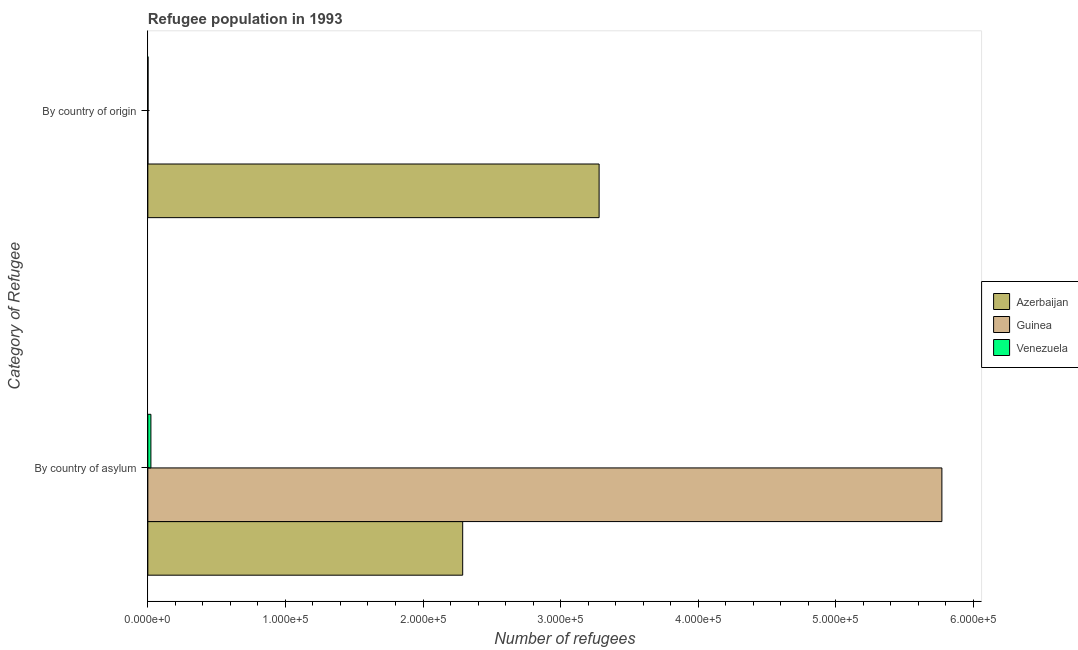How many bars are there on the 2nd tick from the bottom?
Offer a terse response. 3. What is the label of the 2nd group of bars from the top?
Your response must be concise. By country of asylum. What is the number of refugees by country of asylum in Azerbaijan?
Ensure brevity in your answer.  2.29e+05. Across all countries, what is the maximum number of refugees by country of origin?
Your response must be concise. 3.28e+05. Across all countries, what is the minimum number of refugees by country of origin?
Give a very brief answer. 31. In which country was the number of refugees by country of origin maximum?
Provide a succinct answer. Azerbaijan. In which country was the number of refugees by country of origin minimum?
Your answer should be compact. Guinea. What is the total number of refugees by country of asylum in the graph?
Give a very brief answer. 8.08e+05. What is the difference between the number of refugees by country of origin in Venezuela and that in Guinea?
Offer a very short reply. 104. What is the difference between the number of refugees by country of origin in Guinea and the number of refugees by country of asylum in Venezuela?
Your answer should be compact. -2190. What is the average number of refugees by country of asylum per country?
Keep it short and to the point. 2.69e+05. What is the difference between the number of refugees by country of origin and number of refugees by country of asylum in Azerbaijan?
Your response must be concise. 9.92e+04. In how many countries, is the number of refugees by country of asylum greater than 80000 ?
Your answer should be compact. 2. What is the ratio of the number of refugees by country of asylum in Guinea to that in Venezuela?
Give a very brief answer. 259.86. Is the number of refugees by country of origin in Azerbaijan less than that in Venezuela?
Offer a very short reply. No. In how many countries, is the number of refugees by country of origin greater than the average number of refugees by country of origin taken over all countries?
Provide a short and direct response. 1. What does the 1st bar from the top in By country of asylum represents?
Ensure brevity in your answer.  Venezuela. What does the 2nd bar from the bottom in By country of origin represents?
Your answer should be very brief. Guinea. Are all the bars in the graph horizontal?
Provide a succinct answer. Yes. What is the difference between two consecutive major ticks on the X-axis?
Ensure brevity in your answer.  1.00e+05. Are the values on the major ticks of X-axis written in scientific E-notation?
Your answer should be compact. Yes. Does the graph contain any zero values?
Offer a very short reply. No. Does the graph contain grids?
Give a very brief answer. No. How many legend labels are there?
Offer a very short reply. 3. What is the title of the graph?
Make the answer very short. Refugee population in 1993. What is the label or title of the X-axis?
Offer a terse response. Number of refugees. What is the label or title of the Y-axis?
Make the answer very short. Category of Refugee. What is the Number of refugees in Azerbaijan in By country of asylum?
Ensure brevity in your answer.  2.29e+05. What is the Number of refugees of Guinea in By country of asylum?
Keep it short and to the point. 5.77e+05. What is the Number of refugees in Venezuela in By country of asylum?
Your answer should be very brief. 2221. What is the Number of refugees in Azerbaijan in By country of origin?
Provide a short and direct response. 3.28e+05. What is the Number of refugees of Venezuela in By country of origin?
Ensure brevity in your answer.  135. Across all Category of Refugee, what is the maximum Number of refugees in Azerbaijan?
Your answer should be compact. 3.28e+05. Across all Category of Refugee, what is the maximum Number of refugees of Guinea?
Offer a terse response. 5.77e+05. Across all Category of Refugee, what is the maximum Number of refugees in Venezuela?
Your response must be concise. 2221. Across all Category of Refugee, what is the minimum Number of refugees in Azerbaijan?
Your answer should be very brief. 2.29e+05. Across all Category of Refugee, what is the minimum Number of refugees in Venezuela?
Your response must be concise. 135. What is the total Number of refugees of Azerbaijan in the graph?
Keep it short and to the point. 5.57e+05. What is the total Number of refugees of Guinea in the graph?
Offer a terse response. 5.77e+05. What is the total Number of refugees in Venezuela in the graph?
Ensure brevity in your answer.  2356. What is the difference between the Number of refugees of Azerbaijan in By country of asylum and that in By country of origin?
Give a very brief answer. -9.92e+04. What is the difference between the Number of refugees in Guinea in By country of asylum and that in By country of origin?
Keep it short and to the point. 5.77e+05. What is the difference between the Number of refugees in Venezuela in By country of asylum and that in By country of origin?
Make the answer very short. 2086. What is the difference between the Number of refugees of Azerbaijan in By country of asylum and the Number of refugees of Guinea in By country of origin?
Make the answer very short. 2.29e+05. What is the difference between the Number of refugees in Azerbaijan in By country of asylum and the Number of refugees in Venezuela in By country of origin?
Your answer should be very brief. 2.29e+05. What is the difference between the Number of refugees of Guinea in By country of asylum and the Number of refugees of Venezuela in By country of origin?
Provide a short and direct response. 5.77e+05. What is the average Number of refugees in Azerbaijan per Category of Refugee?
Your answer should be compact. 2.78e+05. What is the average Number of refugees in Guinea per Category of Refugee?
Keep it short and to the point. 2.89e+05. What is the average Number of refugees of Venezuela per Category of Refugee?
Give a very brief answer. 1178. What is the difference between the Number of refugees of Azerbaijan and Number of refugees of Guinea in By country of asylum?
Your answer should be very brief. -3.48e+05. What is the difference between the Number of refugees of Azerbaijan and Number of refugees of Venezuela in By country of asylum?
Offer a very short reply. 2.27e+05. What is the difference between the Number of refugees in Guinea and Number of refugees in Venezuela in By country of asylum?
Your answer should be compact. 5.75e+05. What is the difference between the Number of refugees of Azerbaijan and Number of refugees of Guinea in By country of origin?
Ensure brevity in your answer.  3.28e+05. What is the difference between the Number of refugees in Azerbaijan and Number of refugees in Venezuela in By country of origin?
Provide a succinct answer. 3.28e+05. What is the difference between the Number of refugees in Guinea and Number of refugees in Venezuela in By country of origin?
Provide a short and direct response. -104. What is the ratio of the Number of refugees in Azerbaijan in By country of asylum to that in By country of origin?
Give a very brief answer. 0.7. What is the ratio of the Number of refugees of Guinea in By country of asylum to that in By country of origin?
Provide a short and direct response. 1.86e+04. What is the ratio of the Number of refugees in Venezuela in By country of asylum to that in By country of origin?
Provide a short and direct response. 16.45. What is the difference between the highest and the second highest Number of refugees of Azerbaijan?
Ensure brevity in your answer.  9.92e+04. What is the difference between the highest and the second highest Number of refugees of Guinea?
Give a very brief answer. 5.77e+05. What is the difference between the highest and the second highest Number of refugees of Venezuela?
Provide a succinct answer. 2086. What is the difference between the highest and the lowest Number of refugees of Azerbaijan?
Provide a short and direct response. 9.92e+04. What is the difference between the highest and the lowest Number of refugees in Guinea?
Your answer should be very brief. 5.77e+05. What is the difference between the highest and the lowest Number of refugees of Venezuela?
Your answer should be very brief. 2086. 